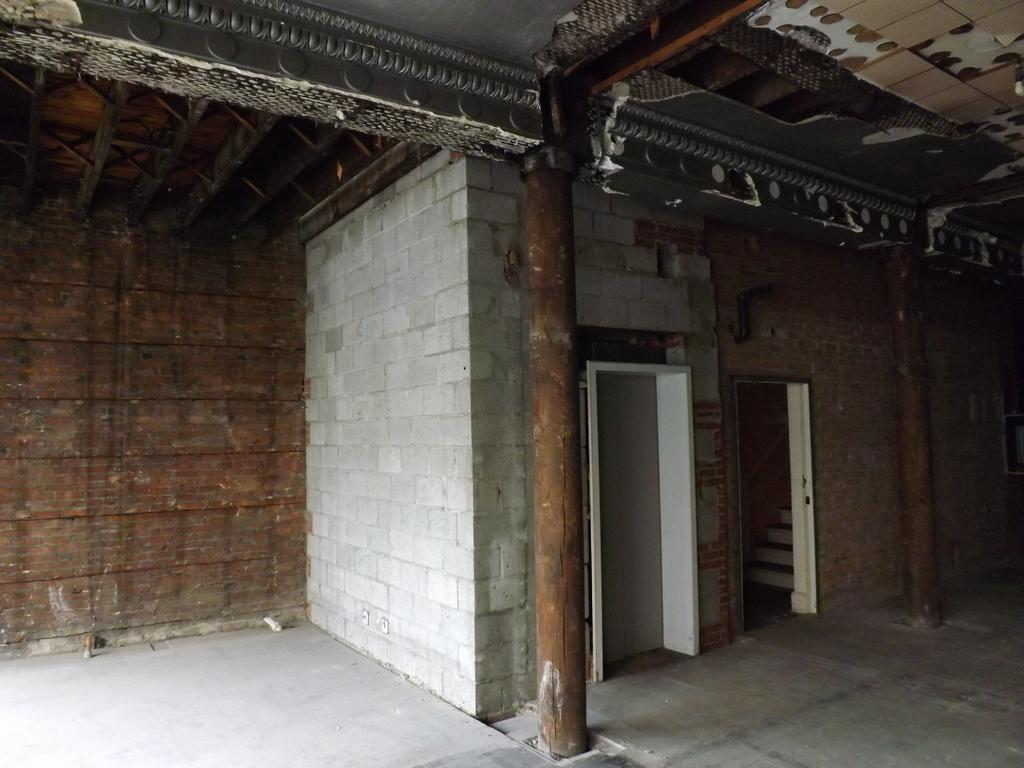What type of architectural feature can be seen in the image? There are doors, stairs, pillars, a roof, and walls visible in the image. Can you describe the structure's layout? The structure has doors, stairs, pillars, a roof, and walls, which suggests it is a building or house. What might be used to support the roof in the image? The pillars in the image might be used to support the roof. What color is the chalk used to draw on the heart in the image? There is no heart or chalk present in the image. Does the rain affect the structure in the image? There is no mention of rain in the image, so it cannot be determined if it affects the structure. 